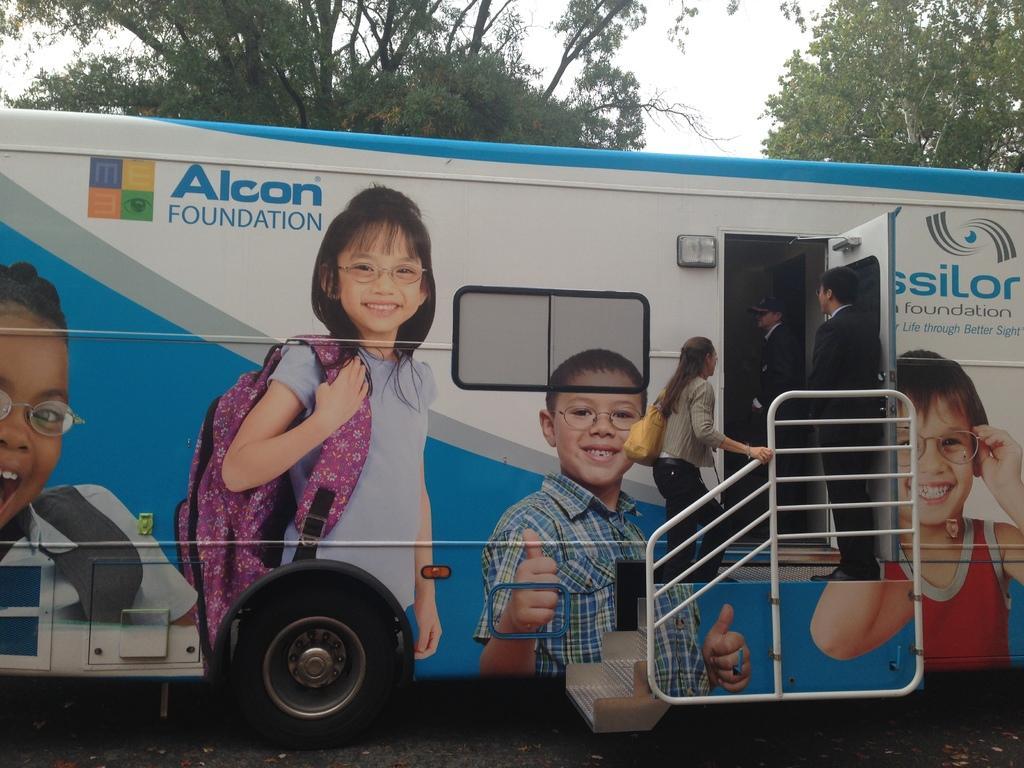Describe this image in one or two sentences. In this image we can see a vehicle on which we can see posters of children smiling. Here we can see the logo. Here we can see a woman climbing the stairs and these two persons are standing here. In the background, we can see trees and the sky. 